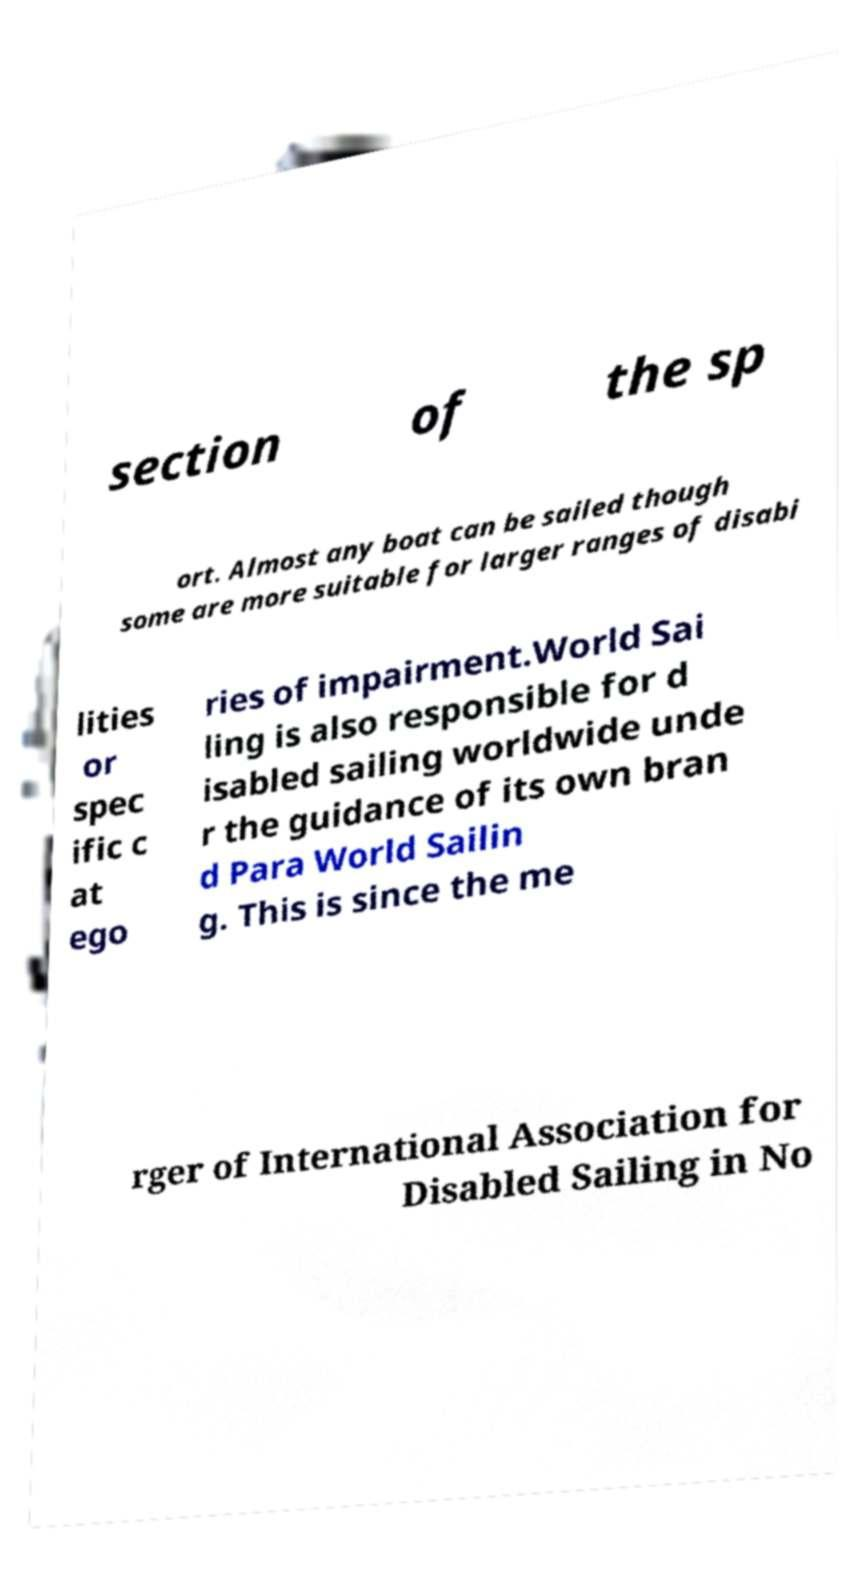I need the written content from this picture converted into text. Can you do that? section of the sp ort. Almost any boat can be sailed though some are more suitable for larger ranges of disabi lities or spec ific c at ego ries of impairment.World Sai ling is also responsible for d isabled sailing worldwide unde r the guidance of its own bran d Para World Sailin g. This is since the me rger of International Association for Disabled Sailing in No 